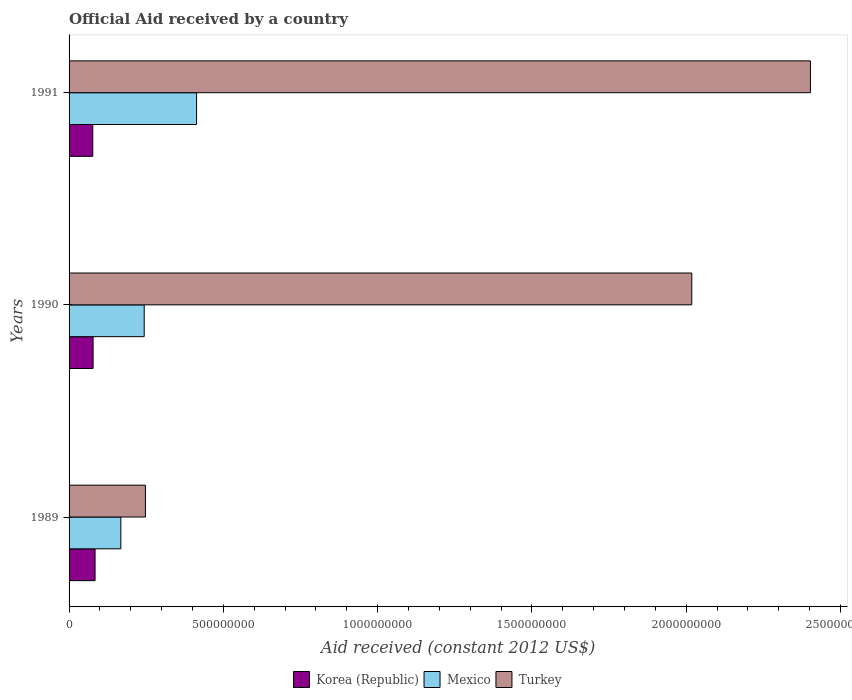Are the number of bars per tick equal to the number of legend labels?
Ensure brevity in your answer.  Yes. What is the net official aid received in Turkey in 1990?
Your answer should be compact. 2.02e+09. Across all years, what is the maximum net official aid received in Korea (Republic)?
Provide a succinct answer. 8.43e+07. Across all years, what is the minimum net official aid received in Turkey?
Your answer should be very brief. 2.47e+08. In which year was the net official aid received in Mexico maximum?
Give a very brief answer. 1991. In which year was the net official aid received in Mexico minimum?
Offer a very short reply. 1989. What is the total net official aid received in Mexico in the graph?
Provide a succinct answer. 8.24e+08. What is the difference between the net official aid received in Turkey in 1990 and that in 1991?
Provide a short and direct response. -3.85e+08. What is the difference between the net official aid received in Mexico in 1990 and the net official aid received in Korea (Republic) in 1989?
Provide a short and direct response. 1.59e+08. What is the average net official aid received in Turkey per year?
Your answer should be compact. 1.56e+09. In the year 1989, what is the difference between the net official aid received in Mexico and net official aid received in Turkey?
Your response must be concise. -7.96e+07. What is the ratio of the net official aid received in Turkey in 1990 to that in 1991?
Give a very brief answer. 0.84. Is the net official aid received in Turkey in 1989 less than that in 1991?
Give a very brief answer. Yes. Is the difference between the net official aid received in Mexico in 1990 and 1991 greater than the difference between the net official aid received in Turkey in 1990 and 1991?
Your answer should be compact. Yes. What is the difference between the highest and the second highest net official aid received in Korea (Republic)?
Offer a terse response. 6.39e+06. What is the difference between the highest and the lowest net official aid received in Mexico?
Offer a terse response. 2.45e+08. In how many years, is the net official aid received in Mexico greater than the average net official aid received in Mexico taken over all years?
Provide a succinct answer. 1. What does the 3rd bar from the top in 1991 represents?
Your answer should be very brief. Korea (Republic). Is it the case that in every year, the sum of the net official aid received in Mexico and net official aid received in Turkey is greater than the net official aid received in Korea (Republic)?
Keep it short and to the point. Yes. Are all the bars in the graph horizontal?
Your answer should be very brief. Yes. Does the graph contain any zero values?
Your answer should be compact. No. What is the title of the graph?
Give a very brief answer. Official Aid received by a country. Does "Euro area" appear as one of the legend labels in the graph?
Your response must be concise. No. What is the label or title of the X-axis?
Give a very brief answer. Aid received (constant 2012 US$). What is the Aid received (constant 2012 US$) in Korea (Republic) in 1989?
Provide a succinct answer. 8.43e+07. What is the Aid received (constant 2012 US$) in Mexico in 1989?
Ensure brevity in your answer.  1.68e+08. What is the Aid received (constant 2012 US$) of Turkey in 1989?
Your response must be concise. 2.47e+08. What is the Aid received (constant 2012 US$) of Korea (Republic) in 1990?
Provide a succinct answer. 7.79e+07. What is the Aid received (constant 2012 US$) of Mexico in 1990?
Offer a terse response. 2.43e+08. What is the Aid received (constant 2012 US$) of Turkey in 1990?
Give a very brief answer. 2.02e+09. What is the Aid received (constant 2012 US$) of Korea (Republic) in 1991?
Offer a terse response. 7.68e+07. What is the Aid received (constant 2012 US$) in Mexico in 1991?
Give a very brief answer. 4.13e+08. What is the Aid received (constant 2012 US$) of Turkey in 1991?
Offer a very short reply. 2.40e+09. Across all years, what is the maximum Aid received (constant 2012 US$) in Korea (Republic)?
Your answer should be compact. 8.43e+07. Across all years, what is the maximum Aid received (constant 2012 US$) of Mexico?
Keep it short and to the point. 4.13e+08. Across all years, what is the maximum Aid received (constant 2012 US$) in Turkey?
Provide a succinct answer. 2.40e+09. Across all years, what is the minimum Aid received (constant 2012 US$) of Korea (Republic)?
Offer a very short reply. 7.68e+07. Across all years, what is the minimum Aid received (constant 2012 US$) in Mexico?
Ensure brevity in your answer.  1.68e+08. Across all years, what is the minimum Aid received (constant 2012 US$) of Turkey?
Keep it short and to the point. 2.47e+08. What is the total Aid received (constant 2012 US$) of Korea (Republic) in the graph?
Your answer should be compact. 2.39e+08. What is the total Aid received (constant 2012 US$) in Mexico in the graph?
Offer a very short reply. 8.24e+08. What is the total Aid received (constant 2012 US$) of Turkey in the graph?
Keep it short and to the point. 4.67e+09. What is the difference between the Aid received (constant 2012 US$) in Korea (Republic) in 1989 and that in 1990?
Your answer should be very brief. 6.39e+06. What is the difference between the Aid received (constant 2012 US$) of Mexico in 1989 and that in 1990?
Offer a terse response. -7.57e+07. What is the difference between the Aid received (constant 2012 US$) in Turkey in 1989 and that in 1990?
Your answer should be compact. -1.77e+09. What is the difference between the Aid received (constant 2012 US$) in Korea (Republic) in 1989 and that in 1991?
Keep it short and to the point. 7.48e+06. What is the difference between the Aid received (constant 2012 US$) of Mexico in 1989 and that in 1991?
Offer a very short reply. -2.45e+08. What is the difference between the Aid received (constant 2012 US$) in Turkey in 1989 and that in 1991?
Your answer should be compact. -2.16e+09. What is the difference between the Aid received (constant 2012 US$) of Korea (Republic) in 1990 and that in 1991?
Provide a succinct answer. 1.09e+06. What is the difference between the Aid received (constant 2012 US$) in Mexico in 1990 and that in 1991?
Your answer should be very brief. -1.70e+08. What is the difference between the Aid received (constant 2012 US$) of Turkey in 1990 and that in 1991?
Your response must be concise. -3.85e+08. What is the difference between the Aid received (constant 2012 US$) of Korea (Republic) in 1989 and the Aid received (constant 2012 US$) of Mexico in 1990?
Provide a succinct answer. -1.59e+08. What is the difference between the Aid received (constant 2012 US$) in Korea (Republic) in 1989 and the Aid received (constant 2012 US$) in Turkey in 1990?
Make the answer very short. -1.93e+09. What is the difference between the Aid received (constant 2012 US$) in Mexico in 1989 and the Aid received (constant 2012 US$) in Turkey in 1990?
Offer a very short reply. -1.85e+09. What is the difference between the Aid received (constant 2012 US$) in Korea (Republic) in 1989 and the Aid received (constant 2012 US$) in Mexico in 1991?
Provide a short and direct response. -3.29e+08. What is the difference between the Aid received (constant 2012 US$) in Korea (Republic) in 1989 and the Aid received (constant 2012 US$) in Turkey in 1991?
Ensure brevity in your answer.  -2.32e+09. What is the difference between the Aid received (constant 2012 US$) in Mexico in 1989 and the Aid received (constant 2012 US$) in Turkey in 1991?
Make the answer very short. -2.23e+09. What is the difference between the Aid received (constant 2012 US$) of Korea (Republic) in 1990 and the Aid received (constant 2012 US$) of Mexico in 1991?
Provide a succinct answer. -3.35e+08. What is the difference between the Aid received (constant 2012 US$) of Korea (Republic) in 1990 and the Aid received (constant 2012 US$) of Turkey in 1991?
Offer a very short reply. -2.32e+09. What is the difference between the Aid received (constant 2012 US$) in Mexico in 1990 and the Aid received (constant 2012 US$) in Turkey in 1991?
Provide a succinct answer. -2.16e+09. What is the average Aid received (constant 2012 US$) of Korea (Republic) per year?
Provide a short and direct response. 7.96e+07. What is the average Aid received (constant 2012 US$) of Mexico per year?
Your answer should be compact. 2.75e+08. What is the average Aid received (constant 2012 US$) of Turkey per year?
Keep it short and to the point. 1.56e+09. In the year 1989, what is the difference between the Aid received (constant 2012 US$) in Korea (Republic) and Aid received (constant 2012 US$) in Mexico?
Make the answer very short. -8.35e+07. In the year 1989, what is the difference between the Aid received (constant 2012 US$) of Korea (Republic) and Aid received (constant 2012 US$) of Turkey?
Keep it short and to the point. -1.63e+08. In the year 1989, what is the difference between the Aid received (constant 2012 US$) of Mexico and Aid received (constant 2012 US$) of Turkey?
Your response must be concise. -7.96e+07. In the year 1990, what is the difference between the Aid received (constant 2012 US$) of Korea (Republic) and Aid received (constant 2012 US$) of Mexico?
Provide a short and direct response. -1.66e+08. In the year 1990, what is the difference between the Aid received (constant 2012 US$) of Korea (Republic) and Aid received (constant 2012 US$) of Turkey?
Your answer should be compact. -1.94e+09. In the year 1990, what is the difference between the Aid received (constant 2012 US$) of Mexico and Aid received (constant 2012 US$) of Turkey?
Your response must be concise. -1.77e+09. In the year 1991, what is the difference between the Aid received (constant 2012 US$) of Korea (Republic) and Aid received (constant 2012 US$) of Mexico?
Provide a short and direct response. -3.36e+08. In the year 1991, what is the difference between the Aid received (constant 2012 US$) in Korea (Republic) and Aid received (constant 2012 US$) in Turkey?
Keep it short and to the point. -2.33e+09. In the year 1991, what is the difference between the Aid received (constant 2012 US$) in Mexico and Aid received (constant 2012 US$) in Turkey?
Make the answer very short. -1.99e+09. What is the ratio of the Aid received (constant 2012 US$) of Korea (Republic) in 1989 to that in 1990?
Your answer should be very brief. 1.08. What is the ratio of the Aid received (constant 2012 US$) of Mexico in 1989 to that in 1990?
Make the answer very short. 0.69. What is the ratio of the Aid received (constant 2012 US$) in Turkey in 1989 to that in 1990?
Ensure brevity in your answer.  0.12. What is the ratio of the Aid received (constant 2012 US$) in Korea (Republic) in 1989 to that in 1991?
Provide a short and direct response. 1.1. What is the ratio of the Aid received (constant 2012 US$) in Mexico in 1989 to that in 1991?
Your response must be concise. 0.41. What is the ratio of the Aid received (constant 2012 US$) in Turkey in 1989 to that in 1991?
Give a very brief answer. 0.1. What is the ratio of the Aid received (constant 2012 US$) of Korea (Republic) in 1990 to that in 1991?
Your answer should be compact. 1.01. What is the ratio of the Aid received (constant 2012 US$) of Mexico in 1990 to that in 1991?
Provide a short and direct response. 0.59. What is the ratio of the Aid received (constant 2012 US$) of Turkey in 1990 to that in 1991?
Your response must be concise. 0.84. What is the difference between the highest and the second highest Aid received (constant 2012 US$) of Korea (Republic)?
Your answer should be very brief. 6.39e+06. What is the difference between the highest and the second highest Aid received (constant 2012 US$) of Mexico?
Your answer should be very brief. 1.70e+08. What is the difference between the highest and the second highest Aid received (constant 2012 US$) in Turkey?
Make the answer very short. 3.85e+08. What is the difference between the highest and the lowest Aid received (constant 2012 US$) in Korea (Republic)?
Offer a terse response. 7.48e+06. What is the difference between the highest and the lowest Aid received (constant 2012 US$) of Mexico?
Your answer should be compact. 2.45e+08. What is the difference between the highest and the lowest Aid received (constant 2012 US$) in Turkey?
Give a very brief answer. 2.16e+09. 